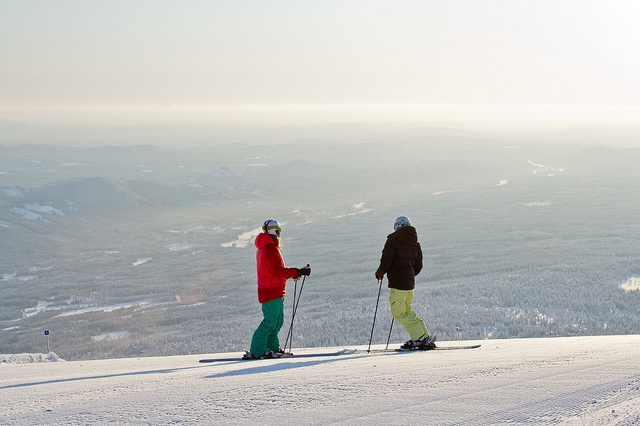Describe the objects in this image and their specific colors. I can see people in lightgray, black, olive, and gray tones, people in lightgray, maroon, brown, teal, and black tones, skis in lightgray, gray, darkblue, and darkgray tones, and skis in lightgray, darkgray, and gray tones in this image. 